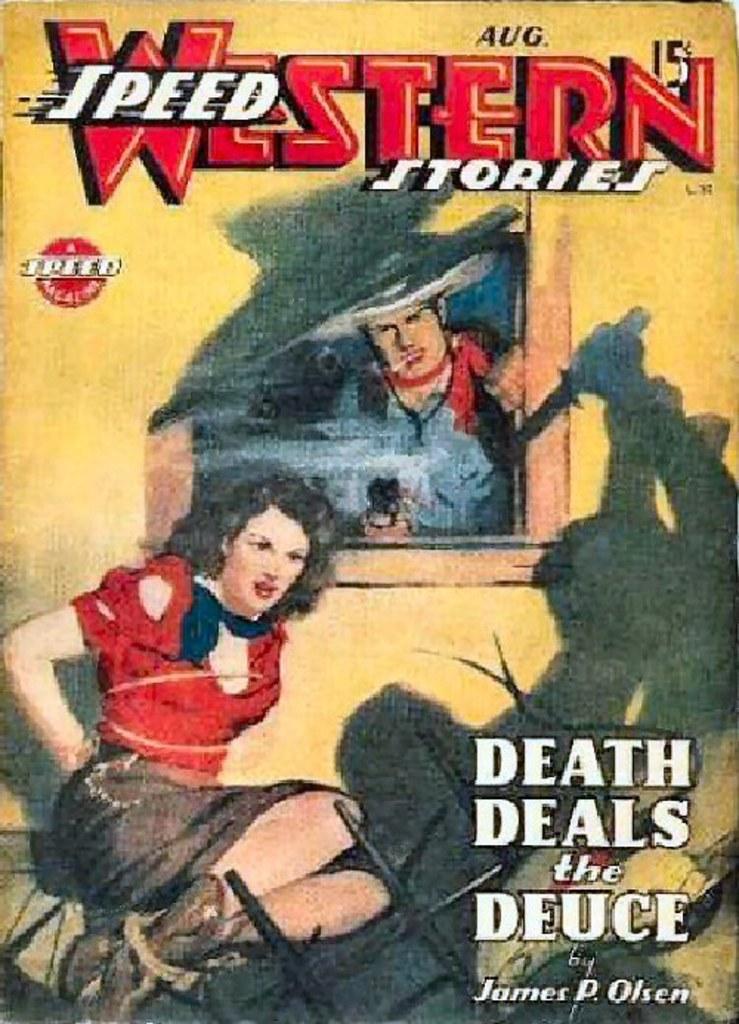Can you describe this image briefly? This is a picture of a poster , where there is a image of two persons , and there are words, numbers and a symbol on the poster. 